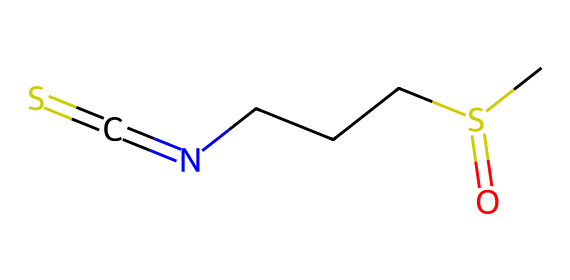What is the primary functional group present in sulforaphane? The chemical structure shows a sulfur atom bonded to a carbon, indicating the presence of a thioketone group where sulfur is involved. This unique functional group is pivotal in defining the properties of sulforaphane.
Answer: thioketone How many carbon atoms are in the structure of sulforaphane? By examining the SMILES representation, there are three 'C' characters which indicate three carbon atoms in the chemical structure.
Answer: 3 What type of bonding is present between the nitrogen and carbon in sulforaphane? The SMILES notation shows a carbon (C) directly double bonded to a nitrogen (N) atom, indicating a carbon-nitrogen double bond which is characteristic of imines.
Answer: double bond What is the total number of atoms in sulforaphane? Counting all types of atoms in the SMILES representation—3 carbon (C), 7 hydrogen (H), 1 nitrogen (N), 1 sulfur (S), and 1 oxygen (O)—the total atom count is 13.
Answer: 13 How does sulforaphane's sulfur atom contribute to its biochemical properties? The presence of sulfur is crucial in organosulfur compounds, which often exhibits antioxidant properties, aiding in various biochemical processes. Therefore, the sulfur atom here suggests that sulforaphane may enhance regenerative properties through redox reactions.
Answer: antioxidant What does the presence of the nitrogen atom imply about sulforaphane? The nitrogen atom indicates that sulforaphane can form imine structures and may interact with biological systems in a way that supports its potential regenerative properties, enhancing its bioactivity.
Answer: bioactivity What environment or conditions might affect the stability of sulforaphane? The stability of sulforaphane can be affected by factors such as pH, temperature, and light exposure, which can lead to the breakdown of its reactive groups, particularly the sulfur-containing moiety.
Answer: instability factors 